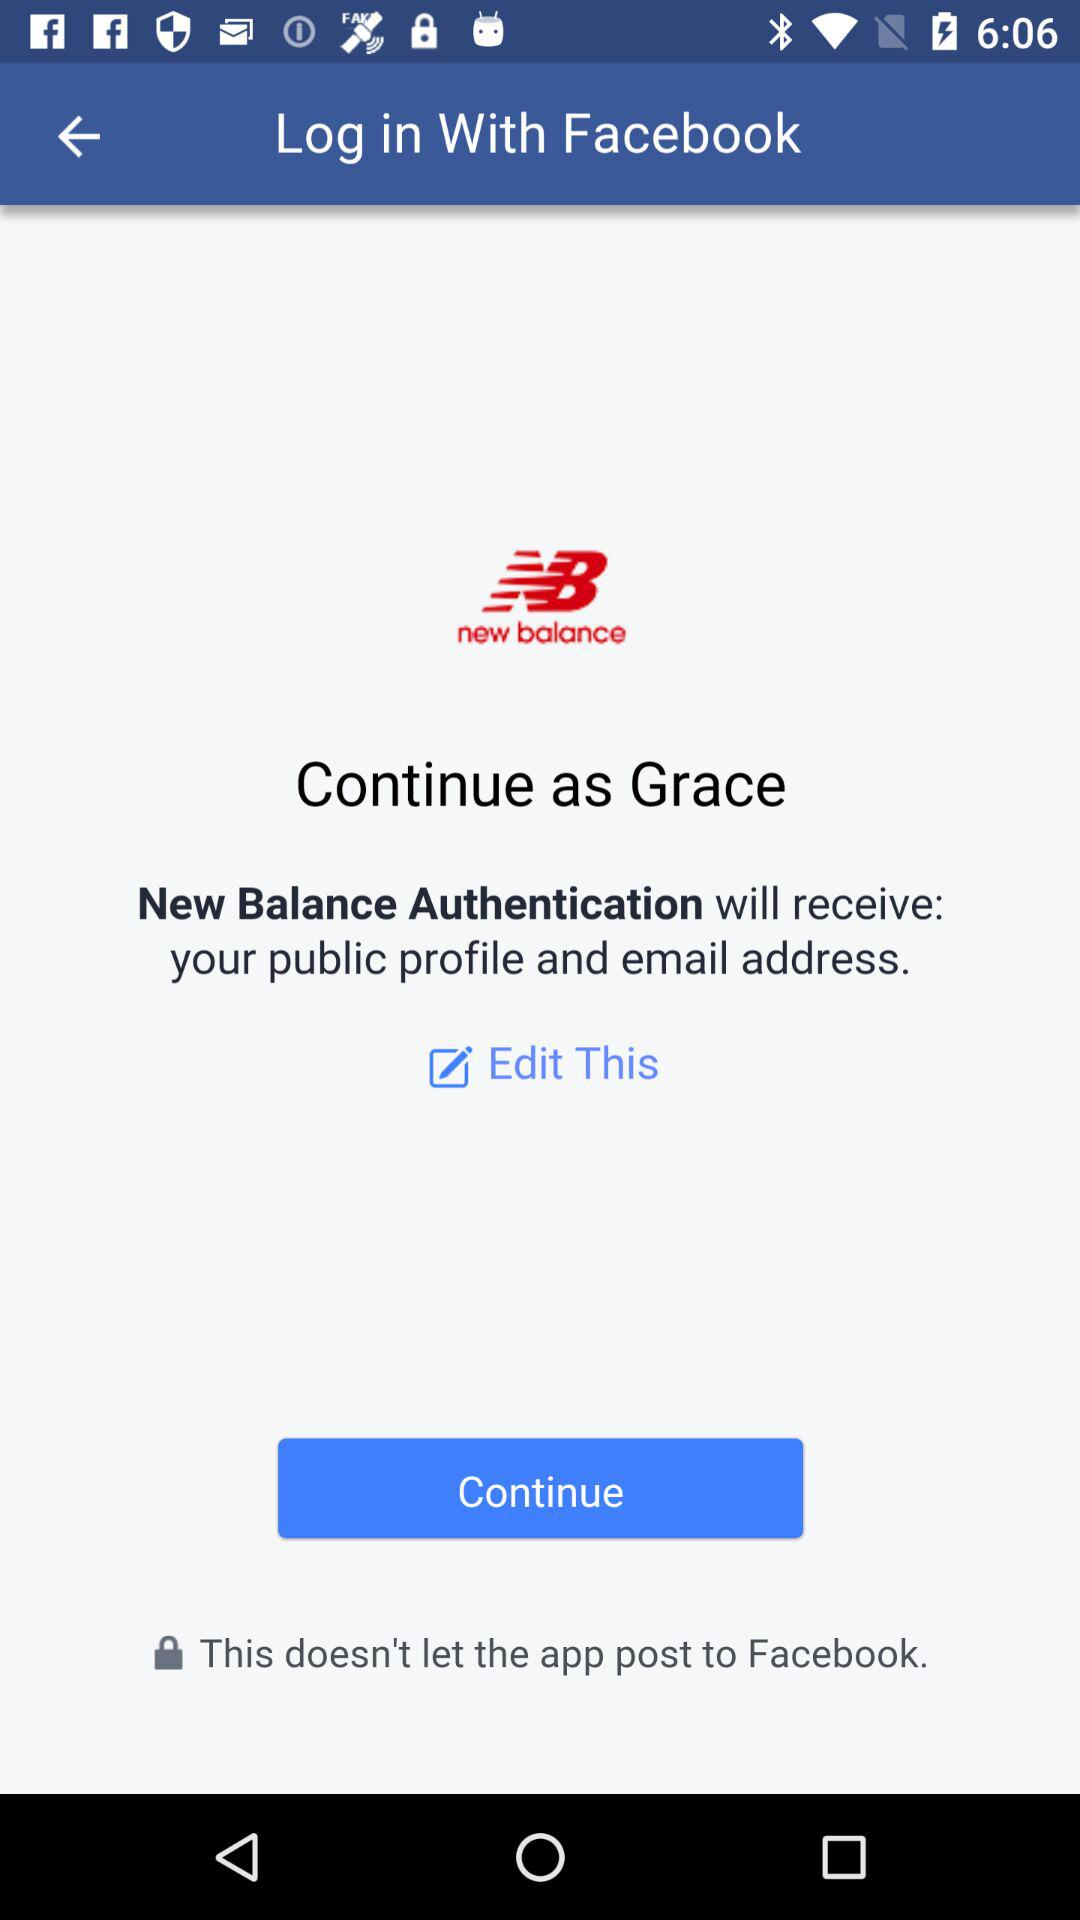What is the name of the user? The name of the user is Grace. 